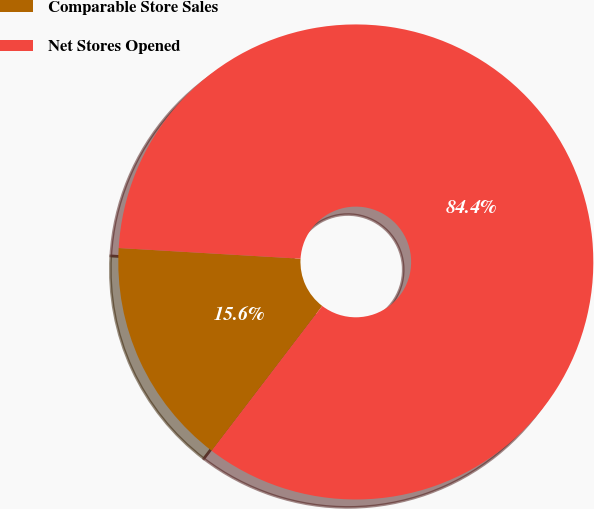Convert chart. <chart><loc_0><loc_0><loc_500><loc_500><pie_chart><fcel>Comparable Store Sales<fcel>Net Stores Opened<nl><fcel>15.56%<fcel>84.44%<nl></chart> 